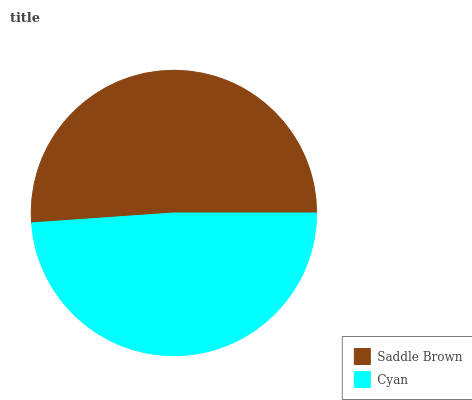Is Cyan the minimum?
Answer yes or no. Yes. Is Saddle Brown the maximum?
Answer yes or no. Yes. Is Cyan the maximum?
Answer yes or no. No. Is Saddle Brown greater than Cyan?
Answer yes or no. Yes. Is Cyan less than Saddle Brown?
Answer yes or no. Yes. Is Cyan greater than Saddle Brown?
Answer yes or no. No. Is Saddle Brown less than Cyan?
Answer yes or no. No. Is Saddle Brown the high median?
Answer yes or no. Yes. Is Cyan the low median?
Answer yes or no. Yes. Is Cyan the high median?
Answer yes or no. No. Is Saddle Brown the low median?
Answer yes or no. No. 